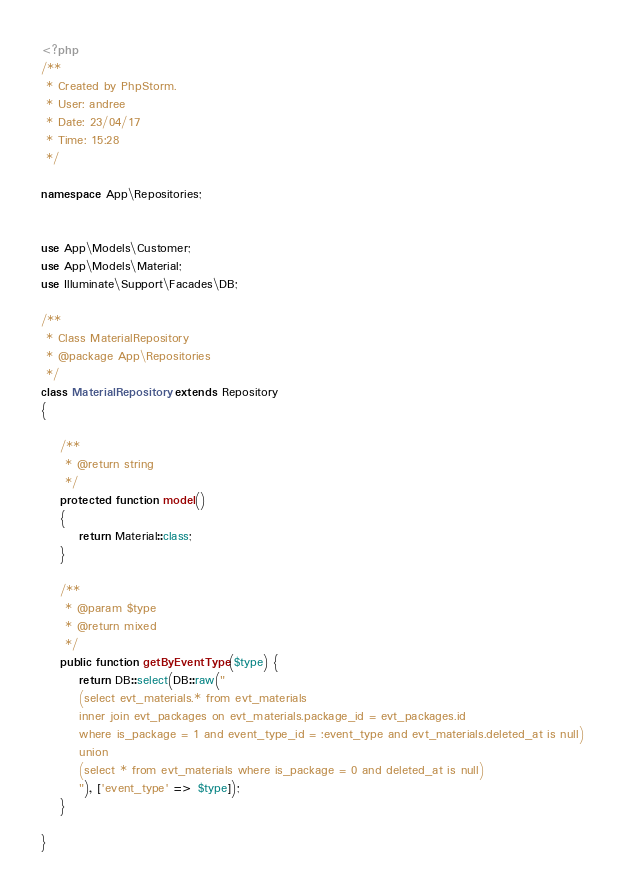<code> <loc_0><loc_0><loc_500><loc_500><_PHP_><?php
/**
 * Created by PhpStorm.
 * User: andree
 * Date: 23/04/17
 * Time: 15:28
 */

namespace App\Repositories;


use App\Models\Customer;
use App\Models\Material;
use Illuminate\Support\Facades\DB;

/**
 * Class MaterialRepository
 * @package App\Repositories
 */
class MaterialRepository extends Repository
{

    /**
     * @return string
     */
    protected function model()
    {
        return Material::class;
    }

    /**
     * @param $type
     * @return mixed
     */
    public function getByEventType($type) {
        return DB::select(DB::raw("
        (select evt_materials.* from evt_materials 
        inner join evt_packages on evt_materials.package_id = evt_packages.id
        where is_package = 1 and event_type_id = :event_type and evt_materials.deleted_at is null) 
        union 
        (select * from evt_materials where is_package = 0 and deleted_at is null)
        "), ['event_type' => $type]);
    }

}</code> 